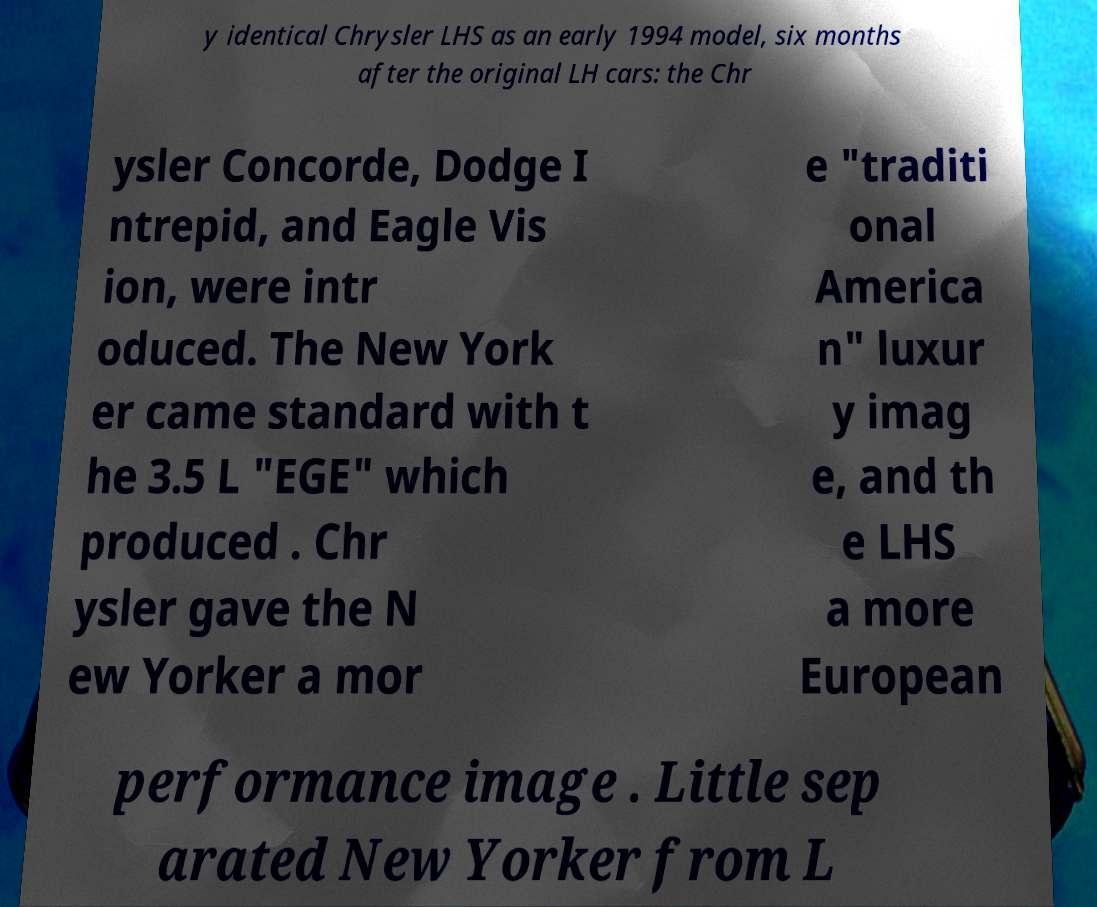Please identify and transcribe the text found in this image. y identical Chrysler LHS as an early 1994 model, six months after the original LH cars: the Chr ysler Concorde, Dodge I ntrepid, and Eagle Vis ion, were intr oduced. The New York er came standard with t he 3.5 L "EGE" which produced . Chr ysler gave the N ew Yorker a mor e "traditi onal America n" luxur y imag e, and th e LHS a more European performance image . Little sep arated New Yorker from L 